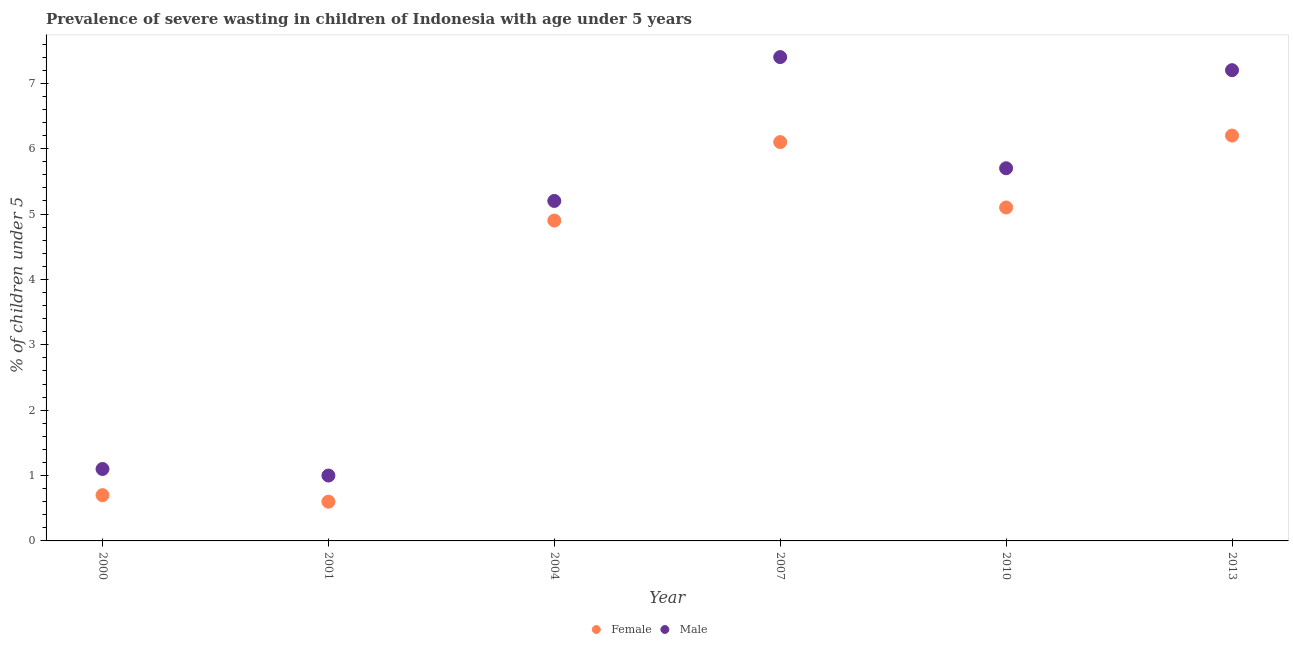Is the number of dotlines equal to the number of legend labels?
Keep it short and to the point. Yes. What is the percentage of undernourished male children in 2013?
Your answer should be very brief. 7.2. Across all years, what is the maximum percentage of undernourished female children?
Your answer should be compact. 6.2. Across all years, what is the minimum percentage of undernourished female children?
Your answer should be compact. 0.6. In which year was the percentage of undernourished female children maximum?
Your answer should be very brief. 2013. What is the total percentage of undernourished male children in the graph?
Provide a succinct answer. 27.6. What is the difference between the percentage of undernourished male children in 2001 and that in 2013?
Provide a succinct answer. -6.2. What is the difference between the percentage of undernourished male children in 2001 and the percentage of undernourished female children in 2010?
Keep it short and to the point. -4.1. What is the average percentage of undernourished male children per year?
Ensure brevity in your answer.  4.6. In the year 2000, what is the difference between the percentage of undernourished male children and percentage of undernourished female children?
Make the answer very short. 0.4. In how many years, is the percentage of undernourished male children greater than 7 %?
Offer a very short reply. 2. What is the ratio of the percentage of undernourished female children in 2007 to that in 2010?
Provide a succinct answer. 1.2. Is the difference between the percentage of undernourished female children in 2007 and 2013 greater than the difference between the percentage of undernourished male children in 2007 and 2013?
Make the answer very short. No. What is the difference between the highest and the second highest percentage of undernourished female children?
Ensure brevity in your answer.  0.1. What is the difference between the highest and the lowest percentage of undernourished male children?
Your response must be concise. 6.4. Is the sum of the percentage of undernourished male children in 2000 and 2010 greater than the maximum percentage of undernourished female children across all years?
Give a very brief answer. Yes. Does the percentage of undernourished female children monotonically increase over the years?
Your response must be concise. No. Is the percentage of undernourished female children strictly less than the percentage of undernourished male children over the years?
Give a very brief answer. Yes. How many years are there in the graph?
Ensure brevity in your answer.  6. What is the difference between two consecutive major ticks on the Y-axis?
Provide a succinct answer. 1. Are the values on the major ticks of Y-axis written in scientific E-notation?
Ensure brevity in your answer.  No. Does the graph contain grids?
Your answer should be compact. No. Where does the legend appear in the graph?
Offer a terse response. Bottom center. What is the title of the graph?
Your answer should be very brief. Prevalence of severe wasting in children of Indonesia with age under 5 years. Does "Under-five" appear as one of the legend labels in the graph?
Give a very brief answer. No. What is the label or title of the Y-axis?
Give a very brief answer.  % of children under 5. What is the  % of children under 5 in Female in 2000?
Your answer should be very brief. 0.7. What is the  % of children under 5 in Male in 2000?
Your answer should be compact. 1.1. What is the  % of children under 5 of Female in 2001?
Give a very brief answer. 0.6. What is the  % of children under 5 of Male in 2001?
Provide a short and direct response. 1. What is the  % of children under 5 of Female in 2004?
Offer a terse response. 4.9. What is the  % of children under 5 in Male in 2004?
Your answer should be compact. 5.2. What is the  % of children under 5 in Female in 2007?
Provide a short and direct response. 6.1. What is the  % of children under 5 of Male in 2007?
Ensure brevity in your answer.  7.4. What is the  % of children under 5 in Female in 2010?
Ensure brevity in your answer.  5.1. What is the  % of children under 5 of Male in 2010?
Ensure brevity in your answer.  5.7. What is the  % of children under 5 in Female in 2013?
Ensure brevity in your answer.  6.2. What is the  % of children under 5 in Male in 2013?
Ensure brevity in your answer.  7.2. Across all years, what is the maximum  % of children under 5 in Female?
Offer a very short reply. 6.2. Across all years, what is the maximum  % of children under 5 in Male?
Give a very brief answer. 7.4. Across all years, what is the minimum  % of children under 5 in Female?
Offer a very short reply. 0.6. Across all years, what is the minimum  % of children under 5 of Male?
Your response must be concise. 1. What is the total  % of children under 5 of Female in the graph?
Make the answer very short. 23.6. What is the total  % of children under 5 of Male in the graph?
Provide a short and direct response. 27.6. What is the difference between the  % of children under 5 in Male in 2000 and that in 2001?
Provide a succinct answer. 0.1. What is the difference between the  % of children under 5 in Male in 2000 and that in 2004?
Your response must be concise. -4.1. What is the difference between the  % of children under 5 of Male in 2000 and that in 2007?
Provide a short and direct response. -6.3. What is the difference between the  % of children under 5 of Female in 2000 and that in 2013?
Provide a succinct answer. -5.5. What is the difference between the  % of children under 5 of Male in 2000 and that in 2013?
Your response must be concise. -6.1. What is the difference between the  % of children under 5 in Male in 2001 and that in 2004?
Offer a terse response. -4.2. What is the difference between the  % of children under 5 in Female in 2001 and that in 2007?
Your answer should be very brief. -5.5. What is the difference between the  % of children under 5 of Female in 2001 and that in 2010?
Provide a short and direct response. -4.5. What is the difference between the  % of children under 5 of Male in 2001 and that in 2010?
Your response must be concise. -4.7. What is the difference between the  % of children under 5 of Female in 2001 and that in 2013?
Your answer should be compact. -5.6. What is the difference between the  % of children under 5 of Female in 2004 and that in 2007?
Provide a succinct answer. -1.2. What is the difference between the  % of children under 5 in Male in 2004 and that in 2007?
Offer a very short reply. -2.2. What is the difference between the  % of children under 5 of Female in 2007 and that in 2013?
Your answer should be very brief. -0.1. What is the difference between the  % of children under 5 of Male in 2007 and that in 2013?
Your answer should be compact. 0.2. What is the difference between the  % of children under 5 of Female in 2000 and the  % of children under 5 of Male in 2001?
Keep it short and to the point. -0.3. What is the difference between the  % of children under 5 in Female in 2000 and the  % of children under 5 in Male in 2013?
Provide a short and direct response. -6.5. What is the difference between the  % of children under 5 in Female in 2001 and the  % of children under 5 in Male in 2013?
Your response must be concise. -6.6. What is the difference between the  % of children under 5 in Female in 2010 and the  % of children under 5 in Male in 2013?
Provide a short and direct response. -2.1. What is the average  % of children under 5 of Female per year?
Keep it short and to the point. 3.93. In the year 2000, what is the difference between the  % of children under 5 in Female and  % of children under 5 in Male?
Offer a terse response. -0.4. In the year 2001, what is the difference between the  % of children under 5 in Female and  % of children under 5 in Male?
Your answer should be very brief. -0.4. In the year 2013, what is the difference between the  % of children under 5 in Female and  % of children under 5 in Male?
Provide a short and direct response. -1. What is the ratio of the  % of children under 5 in Male in 2000 to that in 2001?
Provide a short and direct response. 1.1. What is the ratio of the  % of children under 5 of Female in 2000 to that in 2004?
Provide a short and direct response. 0.14. What is the ratio of the  % of children under 5 of Male in 2000 to that in 2004?
Your response must be concise. 0.21. What is the ratio of the  % of children under 5 in Female in 2000 to that in 2007?
Your response must be concise. 0.11. What is the ratio of the  % of children under 5 of Male in 2000 to that in 2007?
Provide a succinct answer. 0.15. What is the ratio of the  % of children under 5 of Female in 2000 to that in 2010?
Ensure brevity in your answer.  0.14. What is the ratio of the  % of children under 5 of Male in 2000 to that in 2010?
Your answer should be very brief. 0.19. What is the ratio of the  % of children under 5 of Female in 2000 to that in 2013?
Your answer should be compact. 0.11. What is the ratio of the  % of children under 5 of Male in 2000 to that in 2013?
Provide a short and direct response. 0.15. What is the ratio of the  % of children under 5 of Female in 2001 to that in 2004?
Your answer should be compact. 0.12. What is the ratio of the  % of children under 5 of Male in 2001 to that in 2004?
Keep it short and to the point. 0.19. What is the ratio of the  % of children under 5 of Female in 2001 to that in 2007?
Give a very brief answer. 0.1. What is the ratio of the  % of children under 5 in Male in 2001 to that in 2007?
Provide a short and direct response. 0.14. What is the ratio of the  % of children under 5 of Female in 2001 to that in 2010?
Give a very brief answer. 0.12. What is the ratio of the  % of children under 5 of Male in 2001 to that in 2010?
Your answer should be very brief. 0.18. What is the ratio of the  % of children under 5 in Female in 2001 to that in 2013?
Your response must be concise. 0.1. What is the ratio of the  % of children under 5 of Male in 2001 to that in 2013?
Offer a very short reply. 0.14. What is the ratio of the  % of children under 5 in Female in 2004 to that in 2007?
Offer a terse response. 0.8. What is the ratio of the  % of children under 5 of Male in 2004 to that in 2007?
Provide a short and direct response. 0.7. What is the ratio of the  % of children under 5 in Female in 2004 to that in 2010?
Give a very brief answer. 0.96. What is the ratio of the  % of children under 5 of Male in 2004 to that in 2010?
Keep it short and to the point. 0.91. What is the ratio of the  % of children under 5 in Female in 2004 to that in 2013?
Provide a short and direct response. 0.79. What is the ratio of the  % of children under 5 of Male in 2004 to that in 2013?
Ensure brevity in your answer.  0.72. What is the ratio of the  % of children under 5 in Female in 2007 to that in 2010?
Your answer should be compact. 1.2. What is the ratio of the  % of children under 5 in Male in 2007 to that in 2010?
Provide a succinct answer. 1.3. What is the ratio of the  % of children under 5 in Female in 2007 to that in 2013?
Your response must be concise. 0.98. What is the ratio of the  % of children under 5 in Male in 2007 to that in 2013?
Provide a short and direct response. 1.03. What is the ratio of the  % of children under 5 in Female in 2010 to that in 2013?
Make the answer very short. 0.82. What is the ratio of the  % of children under 5 of Male in 2010 to that in 2013?
Offer a very short reply. 0.79. What is the difference between the highest and the second highest  % of children under 5 in Female?
Provide a short and direct response. 0.1. What is the difference between the highest and the lowest  % of children under 5 of Female?
Provide a short and direct response. 5.6. What is the difference between the highest and the lowest  % of children under 5 in Male?
Provide a short and direct response. 6.4. 